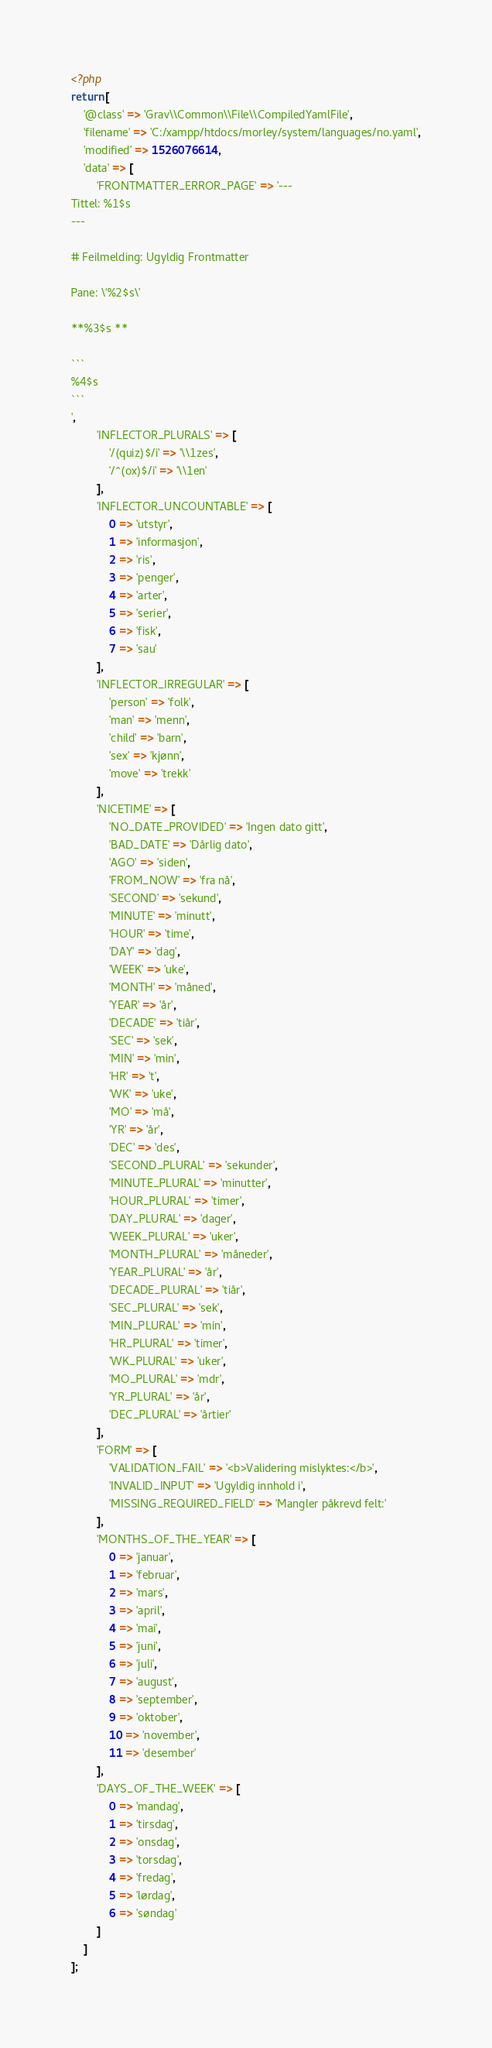<code> <loc_0><loc_0><loc_500><loc_500><_PHP_><?php
return [
    '@class' => 'Grav\\Common\\File\\CompiledYamlFile',
    'filename' => 'C:/xampp/htdocs/morley/system/languages/no.yaml',
    'modified' => 1526076614,
    'data' => [
        'FRONTMATTER_ERROR_PAGE' => '---
Tittel: %1$s
---

# Feilmelding: Ugyldig Frontmatter

Pane: \'%2$s\'

**%3$s **

```
%4$s
```
',
        'INFLECTOR_PLURALS' => [
            '/(quiz)$/i' => '\\1zes',
            '/^(ox)$/i' => '\\1en'
        ],
        'INFLECTOR_UNCOUNTABLE' => [
            0 => 'utstyr',
            1 => 'informasjon',
            2 => 'ris',
            3 => 'penger',
            4 => 'arter',
            5 => 'serier',
            6 => 'fisk',
            7 => 'sau'
        ],
        'INFLECTOR_IRREGULAR' => [
            'person' => 'folk',
            'man' => 'menn',
            'child' => 'barn',
            'sex' => 'kjønn',
            'move' => 'trekk'
        ],
        'NICETIME' => [
            'NO_DATE_PROVIDED' => 'Ingen dato gitt',
            'BAD_DATE' => 'Dårlig dato',
            'AGO' => 'siden',
            'FROM_NOW' => 'fra nå',
            'SECOND' => 'sekund',
            'MINUTE' => 'minutt',
            'HOUR' => 'time',
            'DAY' => 'dag',
            'WEEK' => 'uke',
            'MONTH' => 'måned',
            'YEAR' => 'år',
            'DECADE' => 'tiår',
            'SEC' => 'sek',
            'MIN' => 'min',
            'HR' => 't',
            'WK' => 'uke',
            'MO' => 'må',
            'YR' => 'år',
            'DEC' => 'des',
            'SECOND_PLURAL' => 'sekunder',
            'MINUTE_PLURAL' => 'minutter',
            'HOUR_PLURAL' => 'timer',
            'DAY_PLURAL' => 'dager',
            'WEEK_PLURAL' => 'uker',
            'MONTH_PLURAL' => 'måneder',
            'YEAR_PLURAL' => 'år',
            'DECADE_PLURAL' => 'tiår',
            'SEC_PLURAL' => 'sek',
            'MIN_PLURAL' => 'min',
            'HR_PLURAL' => 'timer',
            'WK_PLURAL' => 'uker',
            'MO_PLURAL' => 'mdr',
            'YR_PLURAL' => 'år',
            'DEC_PLURAL' => 'årtier'
        ],
        'FORM' => [
            'VALIDATION_FAIL' => '<b>Validering mislyktes:</b>',
            'INVALID_INPUT' => 'Ugyldig innhold i',
            'MISSING_REQUIRED_FIELD' => 'Mangler påkrevd felt:'
        ],
        'MONTHS_OF_THE_YEAR' => [
            0 => 'januar',
            1 => 'februar',
            2 => 'mars',
            3 => 'april',
            4 => 'mai',
            5 => 'juni',
            6 => 'juli',
            7 => 'august',
            8 => 'september',
            9 => 'oktober',
            10 => 'november',
            11 => 'desember'
        ],
        'DAYS_OF_THE_WEEK' => [
            0 => 'mandag',
            1 => 'tirsdag',
            2 => 'onsdag',
            3 => 'torsdag',
            4 => 'fredag',
            5 => 'lørdag',
            6 => 'søndag'
        ]
    ]
];
</code> 